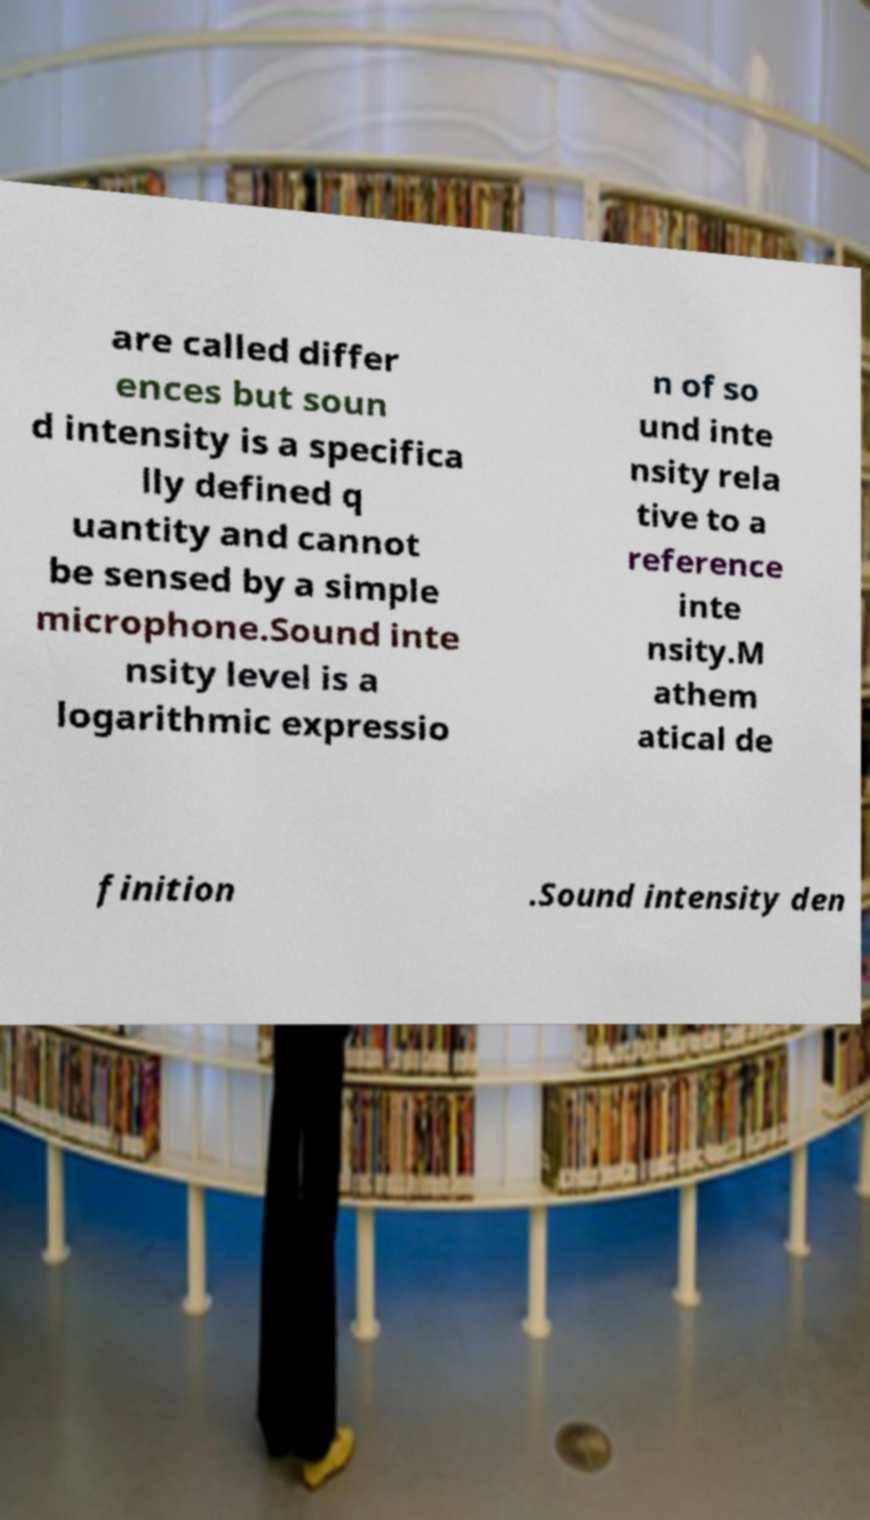There's text embedded in this image that I need extracted. Can you transcribe it verbatim? are called differ ences but soun d intensity is a specifica lly defined q uantity and cannot be sensed by a simple microphone.Sound inte nsity level is a logarithmic expressio n of so und inte nsity rela tive to a reference inte nsity.M athem atical de finition .Sound intensity den 